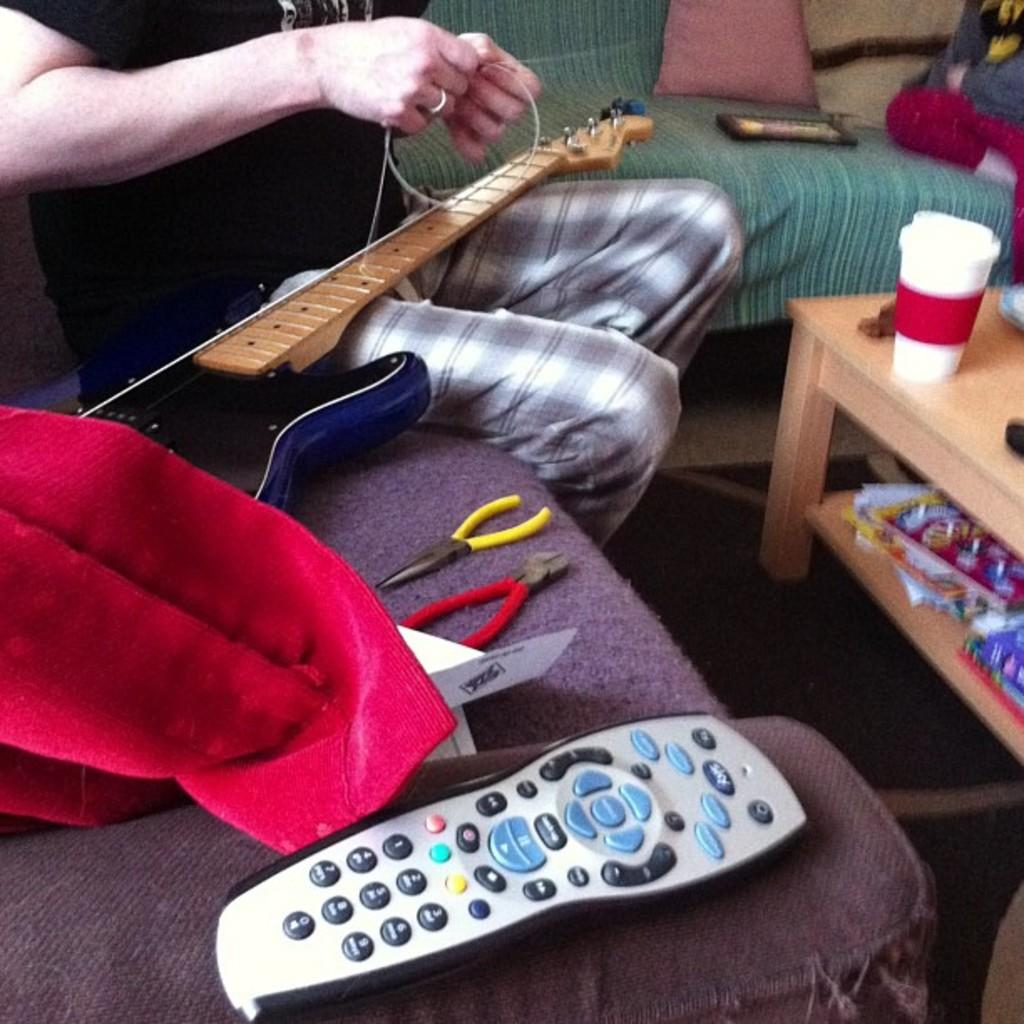Provide a one-sentence caption for the provided image. Someone stringing a guitar on a couch next to plyers and a remote control. 